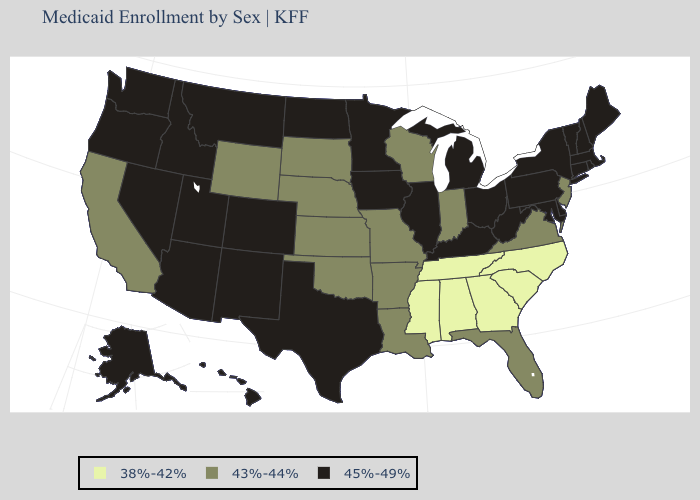What is the lowest value in the USA?
Be succinct. 38%-42%. Does the first symbol in the legend represent the smallest category?
Be succinct. Yes. Does Alaska have a higher value than West Virginia?
Quick response, please. No. What is the highest value in the USA?
Answer briefly. 45%-49%. Does Florida have a lower value than Ohio?
Give a very brief answer. Yes. Does Alaska have the lowest value in the West?
Quick response, please. No. Among the states that border Maine , which have the lowest value?
Concise answer only. New Hampshire. What is the lowest value in states that border Texas?
Write a very short answer. 43%-44%. What is the value of Mississippi?
Answer briefly. 38%-42%. Name the states that have a value in the range 43%-44%?
Concise answer only. Arkansas, California, Florida, Indiana, Kansas, Louisiana, Missouri, Nebraska, New Jersey, Oklahoma, South Dakota, Virginia, Wisconsin, Wyoming. What is the value of California?
Short answer required. 43%-44%. Name the states that have a value in the range 45%-49%?
Concise answer only. Alaska, Arizona, Colorado, Connecticut, Delaware, Hawaii, Idaho, Illinois, Iowa, Kentucky, Maine, Maryland, Massachusetts, Michigan, Minnesota, Montana, Nevada, New Hampshire, New Mexico, New York, North Dakota, Ohio, Oregon, Pennsylvania, Rhode Island, Texas, Utah, Vermont, Washington, West Virginia. Does Utah have a lower value than Virginia?
Give a very brief answer. No. 